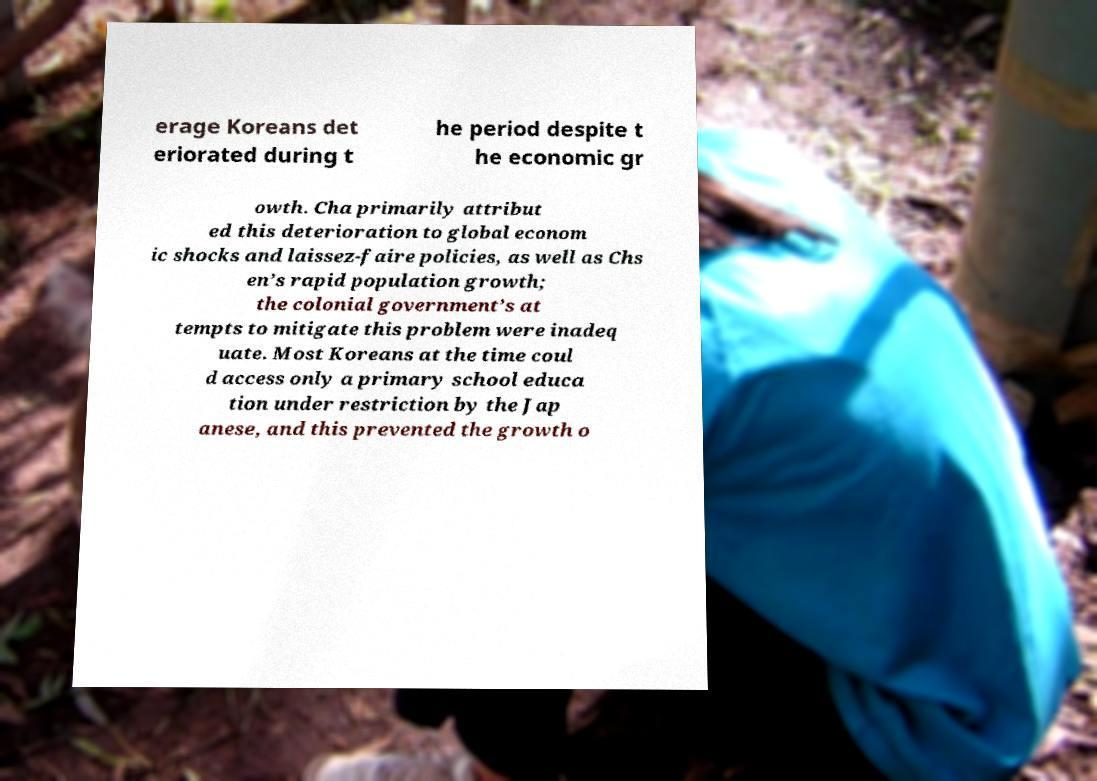I need the written content from this picture converted into text. Can you do that? erage Koreans det eriorated during t he period despite t he economic gr owth. Cha primarily attribut ed this deterioration to global econom ic shocks and laissez-faire policies, as well as Chs en’s rapid population growth; the colonial government’s at tempts to mitigate this problem were inadeq uate. Most Koreans at the time coul d access only a primary school educa tion under restriction by the Jap anese, and this prevented the growth o 